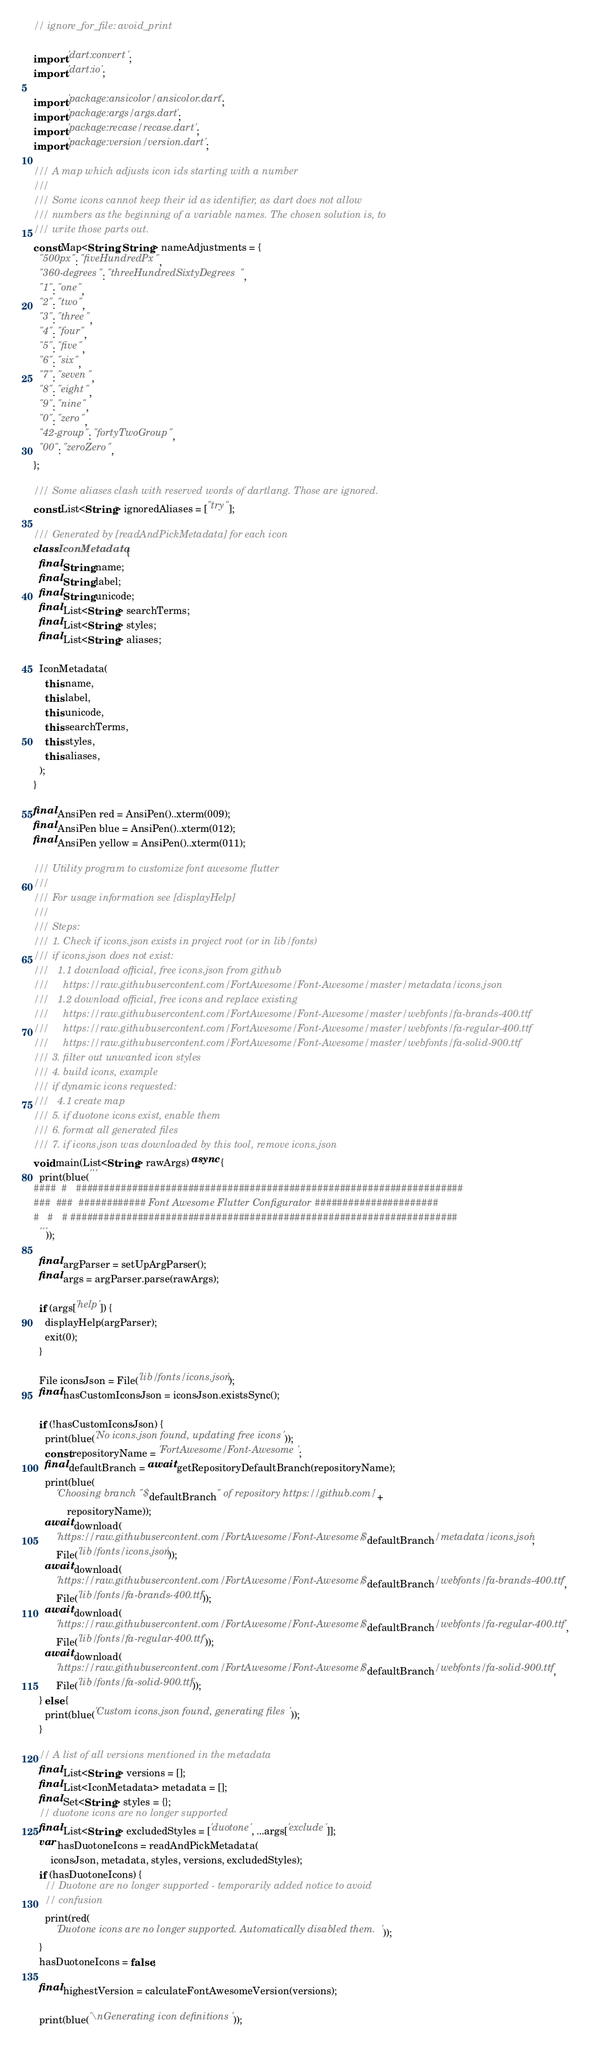Convert code to text. <code><loc_0><loc_0><loc_500><loc_500><_Dart_>// ignore_for_file: avoid_print

import 'dart:convert';
import 'dart:io';

import 'package:ansicolor/ansicolor.dart';
import 'package:args/args.dart';
import 'package:recase/recase.dart';
import 'package:version/version.dart';

/// A map which adjusts icon ids starting with a number
///
/// Some icons cannot keep their id as identifier, as dart does not allow
/// numbers as the beginning of a variable names. The chosen solution is, to
/// write those parts out.
const Map<String, String> nameAdjustments = {
  "500px": "fiveHundredPx",
  "360-degrees": "threeHundredSixtyDegrees",
  "1": "one",
  "2": "two",
  "3": "three",
  "4": "four",
  "5": "five",
  "6": "six",
  "7": "seven",
  "8": "eight",
  "9": "nine",
  "0": "zero",
  "42-group": "fortyTwoGroup",
  "00": "zeroZero",
};

/// Some aliases clash with reserved words of dartlang. Those are ignored.
const List<String> ignoredAliases = ["try"];

/// Generated by [readAndPickMetadata] for each icon
class IconMetadata {
  final String name;
  final String label;
  final String unicode;
  final List<String> searchTerms;
  final List<String> styles;
  final List<String> aliases;

  IconMetadata(
    this.name,
    this.label,
    this.unicode,
    this.searchTerms,
    this.styles,
    this.aliases,
  );
}

final AnsiPen red = AnsiPen()..xterm(009);
final AnsiPen blue = AnsiPen()..xterm(012);
final AnsiPen yellow = AnsiPen()..xterm(011);

/// Utility program to customize font awesome flutter
///
/// For usage information see [displayHelp]
///
/// Steps:
/// 1. Check if icons.json exists in project root (or in lib/fonts)
/// if icons.json does not exist:
///   1.1 download official, free icons.json from github
///     https://raw.githubusercontent.com/FortAwesome/Font-Awesome/master/metadata/icons.json
///   1.2 download official, free icons and replace existing
///     https://raw.githubusercontent.com/FortAwesome/Font-Awesome/master/webfonts/fa-brands-400.ttf
///     https://raw.githubusercontent.com/FortAwesome/Font-Awesome/master/webfonts/fa-regular-400.ttf
///     https://raw.githubusercontent.com/FortAwesome/Font-Awesome/master/webfonts/fa-solid-900.ttf
/// 3. filter out unwanted icon styles
/// 4. build icons, example
/// if dynamic icons requested:
///   4.1 create map
/// 5. if duotone icons exist, enable them
/// 6. format all generated files
/// 7. if icons.json was downloaded by this tool, remove icons.json
void main(List<String> rawArgs) async {
  print(blue('''
####  #   #####################################################################
###  ###  ############ Font Awesome Flutter Configurator ######################
#   #   # #####################################################################
  '''));

  final argParser = setUpArgParser();
  final args = argParser.parse(rawArgs);

  if (args['help']) {
    displayHelp(argParser);
    exit(0);
  }

  File iconsJson = File('lib/fonts/icons.json');
  final hasCustomIconsJson = iconsJson.existsSync();

  if (!hasCustomIconsJson) {
    print(blue('No icons.json found, updating free icons'));
    const repositoryName = 'FortAwesome/Font-Awesome';
    final defaultBranch = await getRepositoryDefaultBranch(repositoryName);
    print(blue(
        'Choosing branch "$defaultBranch" of repository https://github.com/' +
            repositoryName));
    await download(
        'https://raw.githubusercontent.com/FortAwesome/Font-Awesome/$defaultBranch/metadata/icons.json',
        File('lib/fonts/icons.json'));
    await download(
        'https://raw.githubusercontent.com/FortAwesome/Font-Awesome/$defaultBranch/webfonts/fa-brands-400.ttf',
        File('lib/fonts/fa-brands-400.ttf'));
    await download(
        'https://raw.githubusercontent.com/FortAwesome/Font-Awesome/$defaultBranch/webfonts/fa-regular-400.ttf',
        File('lib/fonts/fa-regular-400.ttf'));
    await download(
        'https://raw.githubusercontent.com/FortAwesome/Font-Awesome/$defaultBranch/webfonts/fa-solid-900.ttf',
        File('lib/fonts/fa-solid-900.ttf'));
  } else {
    print(blue('Custom icons.json found, generating files'));
  }

  // A list of all versions mentioned in the metadata
  final List<String> versions = [];
  final List<IconMetadata> metadata = [];
  final Set<String> styles = {};
  // duotone icons are no longer supported
  final List<String> excludedStyles = ['duotone', ...args['exclude']];
  var hasDuotoneIcons = readAndPickMetadata(
      iconsJson, metadata, styles, versions, excludedStyles);
  if (hasDuotoneIcons) {
    // Duotone are no longer supported - temporarily added notice to avoid
    // confusion
    print(red(
        'Duotone icons are no longer supported. Automatically disabled them.'));
  }
  hasDuotoneIcons = false;

  final highestVersion = calculateFontAwesomeVersion(versions);

  print(blue('\nGenerating icon definitions'));</code> 